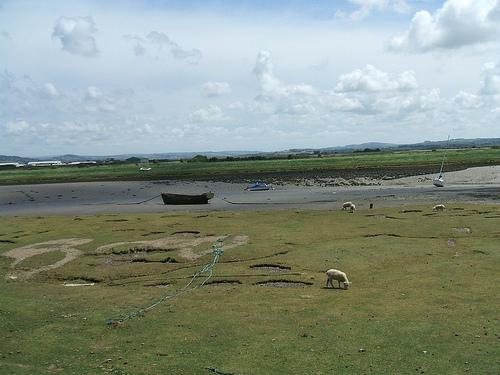What type of boats can be seen on the shore? A brown boat, a white sailboat, and a blue and white speedboat are on the shore. What kind of holes can be found in the area, and where are they located? Sinkholes and shallow holes can be found, located on the grass. What is unique about the sailboat in the image? The sailboat is on its side in the sand, leaning to one side. Explain the state of the tide and its relation to the boats. The tide is out, leaving the boats stranded on the sandy shore. Identify the animal in the image and where it is standing. A sheep is standing on the grass, grazing. Describe the scenery in the background of the image. Mountains can be seen in the background, with a bright blue and white sky filled with puffy white clouds. How many sheep are present in the image, and what are they doing? There are four sheep on the grass, grazing. Are there any structures or buildings in the image? If so, provide their location. Yes, there are buildings in the distance and a structure sitting in the grass. What kind of wire can be seen in the image? Where is it located? Green wires can be seen running along the grass. Name the distinct colors of the boats in the image. White, brown, and blue are the distinct colors of the boats in the picture. 